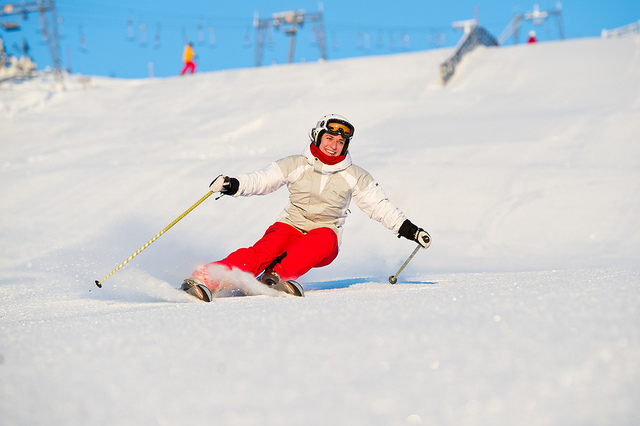Describe the current conditions on the ski slope. The ski slope appears to be well-groomed with a fresh layer of snow, ideal for skiing. The weather seems clear with sunlight enhancing visibility. Such conditions are perfect for skiers looking for smooth runs. 